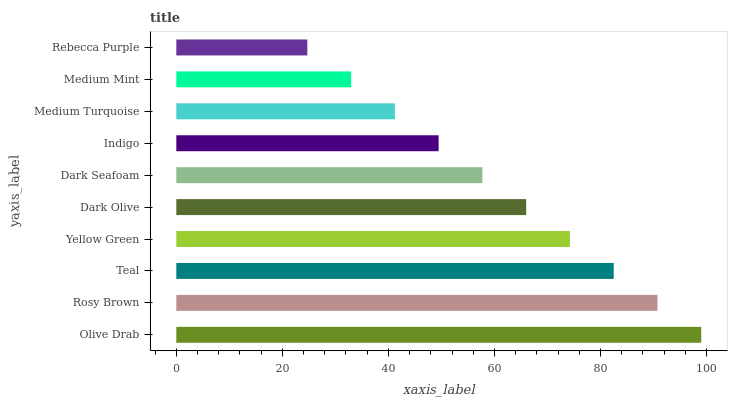Is Rebecca Purple the minimum?
Answer yes or no. Yes. Is Olive Drab the maximum?
Answer yes or no. Yes. Is Rosy Brown the minimum?
Answer yes or no. No. Is Rosy Brown the maximum?
Answer yes or no. No. Is Olive Drab greater than Rosy Brown?
Answer yes or no. Yes. Is Rosy Brown less than Olive Drab?
Answer yes or no. Yes. Is Rosy Brown greater than Olive Drab?
Answer yes or no. No. Is Olive Drab less than Rosy Brown?
Answer yes or no. No. Is Dark Olive the high median?
Answer yes or no. Yes. Is Dark Seafoam the low median?
Answer yes or no. Yes. Is Rebecca Purple the high median?
Answer yes or no. No. Is Indigo the low median?
Answer yes or no. No. 